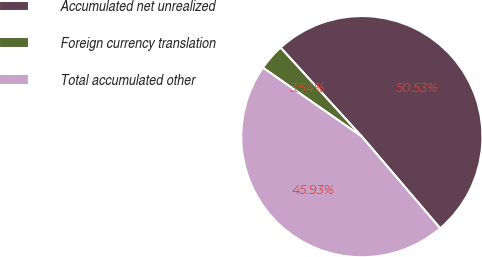<chart> <loc_0><loc_0><loc_500><loc_500><pie_chart><fcel>Accumulated net unrealized<fcel>Foreign currency translation<fcel>Total accumulated other<nl><fcel>50.53%<fcel>3.54%<fcel>45.93%<nl></chart> 